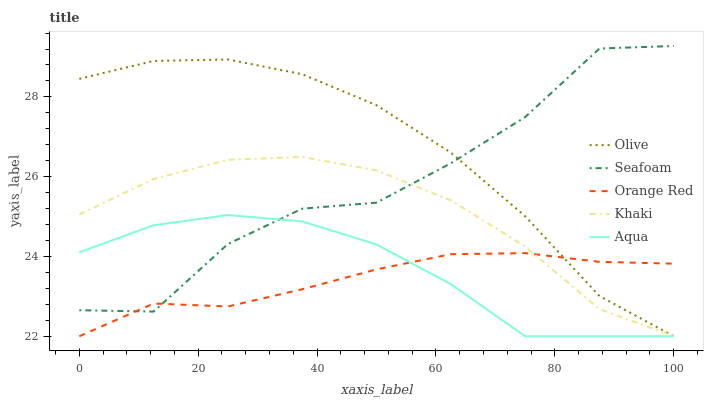Does Orange Red have the minimum area under the curve?
Answer yes or no. Yes. Does Olive have the maximum area under the curve?
Answer yes or no. Yes. Does Khaki have the minimum area under the curve?
Answer yes or no. No. Does Khaki have the maximum area under the curve?
Answer yes or no. No. Is Orange Red the smoothest?
Answer yes or no. Yes. Is Seafoam the roughest?
Answer yes or no. Yes. Is Khaki the smoothest?
Answer yes or no. No. Is Khaki the roughest?
Answer yes or no. No. Does Seafoam have the lowest value?
Answer yes or no. No. Does Seafoam have the highest value?
Answer yes or no. Yes. Does Khaki have the highest value?
Answer yes or no. No. Does Khaki intersect Olive?
Answer yes or no. Yes. Is Khaki less than Olive?
Answer yes or no. No. Is Khaki greater than Olive?
Answer yes or no. No. 